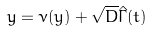<formula> <loc_0><loc_0><loc_500><loc_500>\dot { y } = \nu ( y ) + \sqrt { D } \hat { \Gamma } ( t )</formula> 